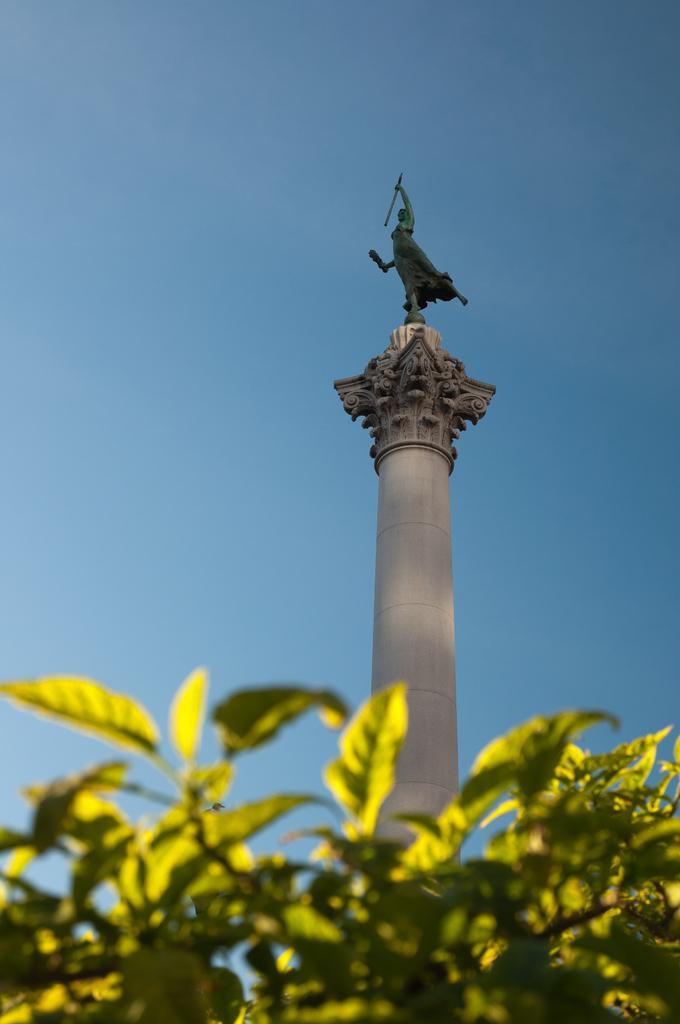Can you describe this image briefly? This image is taken outdoors. In the background there is the sky. In the middle of the image there is a pillar with a few carvings on it and there is a statue on the pillar. At the bottom of the image there is a plant with leaves and stems. 